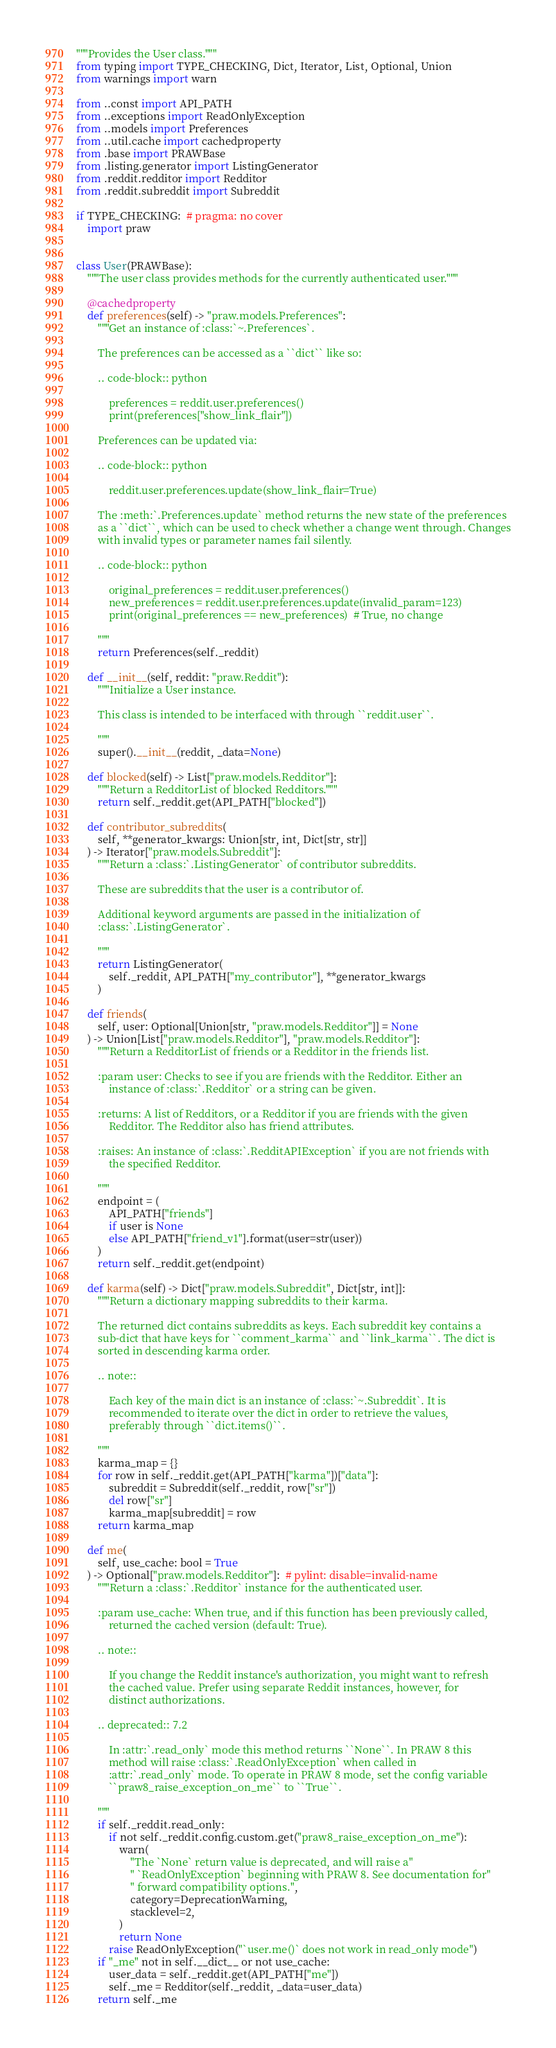Convert code to text. <code><loc_0><loc_0><loc_500><loc_500><_Python_>"""Provides the User class."""
from typing import TYPE_CHECKING, Dict, Iterator, List, Optional, Union
from warnings import warn

from ..const import API_PATH
from ..exceptions import ReadOnlyException
from ..models import Preferences
from ..util.cache import cachedproperty
from .base import PRAWBase
from .listing.generator import ListingGenerator
from .reddit.redditor import Redditor
from .reddit.subreddit import Subreddit

if TYPE_CHECKING:  # pragma: no cover
    import praw


class User(PRAWBase):
    """The user class provides methods for the currently authenticated user."""

    @cachedproperty
    def preferences(self) -> "praw.models.Preferences":
        """Get an instance of :class:`~.Preferences`.

        The preferences can be accessed as a ``dict`` like so:

        .. code-block:: python

            preferences = reddit.user.preferences()
            print(preferences["show_link_flair"])

        Preferences can be updated via:

        .. code-block:: python

            reddit.user.preferences.update(show_link_flair=True)

        The :meth:`.Preferences.update` method returns the new state of the preferences
        as a ``dict``, which can be used to check whether a change went through. Changes
        with invalid types or parameter names fail silently.

        .. code-block:: python

            original_preferences = reddit.user.preferences()
            new_preferences = reddit.user.preferences.update(invalid_param=123)
            print(original_preferences == new_preferences)  # True, no change

        """
        return Preferences(self._reddit)

    def __init__(self, reddit: "praw.Reddit"):
        """Initialize a User instance.

        This class is intended to be interfaced with through ``reddit.user``.

        """
        super().__init__(reddit, _data=None)

    def blocked(self) -> List["praw.models.Redditor"]:
        """Return a RedditorList of blocked Redditors."""
        return self._reddit.get(API_PATH["blocked"])

    def contributor_subreddits(
        self, **generator_kwargs: Union[str, int, Dict[str, str]]
    ) -> Iterator["praw.models.Subreddit"]:
        """Return a :class:`.ListingGenerator` of contributor subreddits.

        These are subreddits that the user is a contributor of.

        Additional keyword arguments are passed in the initialization of
        :class:`.ListingGenerator`.

        """
        return ListingGenerator(
            self._reddit, API_PATH["my_contributor"], **generator_kwargs
        )

    def friends(
        self, user: Optional[Union[str, "praw.models.Redditor"]] = None
    ) -> Union[List["praw.models.Redditor"], "praw.models.Redditor"]:
        """Return a RedditorList of friends or a Redditor in the friends list.

        :param user: Checks to see if you are friends with the Redditor. Either an
            instance of :class:`.Redditor` or a string can be given.

        :returns: A list of Redditors, or a Redditor if you are friends with the given
            Redditor. The Redditor also has friend attributes.

        :raises: An instance of :class:`.RedditAPIException` if you are not friends with
            the specified Redditor.

        """
        endpoint = (
            API_PATH["friends"]
            if user is None
            else API_PATH["friend_v1"].format(user=str(user))
        )
        return self._reddit.get(endpoint)

    def karma(self) -> Dict["praw.models.Subreddit", Dict[str, int]]:
        """Return a dictionary mapping subreddits to their karma.

        The returned dict contains subreddits as keys. Each subreddit key contains a
        sub-dict that have keys for ``comment_karma`` and ``link_karma``. The dict is
        sorted in descending karma order.

        .. note::

            Each key of the main dict is an instance of :class:`~.Subreddit`. It is
            recommended to iterate over the dict in order to retrieve the values,
            preferably through ``dict.items()``.

        """
        karma_map = {}
        for row in self._reddit.get(API_PATH["karma"])["data"]:
            subreddit = Subreddit(self._reddit, row["sr"])
            del row["sr"]
            karma_map[subreddit] = row
        return karma_map

    def me(
        self, use_cache: bool = True
    ) -> Optional["praw.models.Redditor"]:  # pylint: disable=invalid-name
        """Return a :class:`.Redditor` instance for the authenticated user.

        :param use_cache: When true, and if this function has been previously called,
            returned the cached version (default: True).

        .. note::

            If you change the Reddit instance's authorization, you might want to refresh
            the cached value. Prefer using separate Reddit instances, however, for
            distinct authorizations.

        .. deprecated:: 7.2

            In :attr:`.read_only` mode this method returns ``None``. In PRAW 8 this
            method will raise :class:`.ReadOnlyException` when called in
            :attr:`.read_only` mode. To operate in PRAW 8 mode, set the config variable
            ``praw8_raise_exception_on_me`` to ``True``.

        """
        if self._reddit.read_only:
            if not self._reddit.config.custom.get("praw8_raise_exception_on_me"):
                warn(
                    "The `None` return value is deprecated, and will raise a"
                    " `ReadOnlyException` beginning with PRAW 8. See documentation for"
                    " forward compatibility options.",
                    category=DeprecationWarning,
                    stacklevel=2,
                )
                return None
            raise ReadOnlyException("`user.me()` does not work in read_only mode")
        if "_me" not in self.__dict__ or not use_cache:
            user_data = self._reddit.get(API_PATH["me"])
            self._me = Redditor(self._reddit, _data=user_data)
        return self._me
</code> 